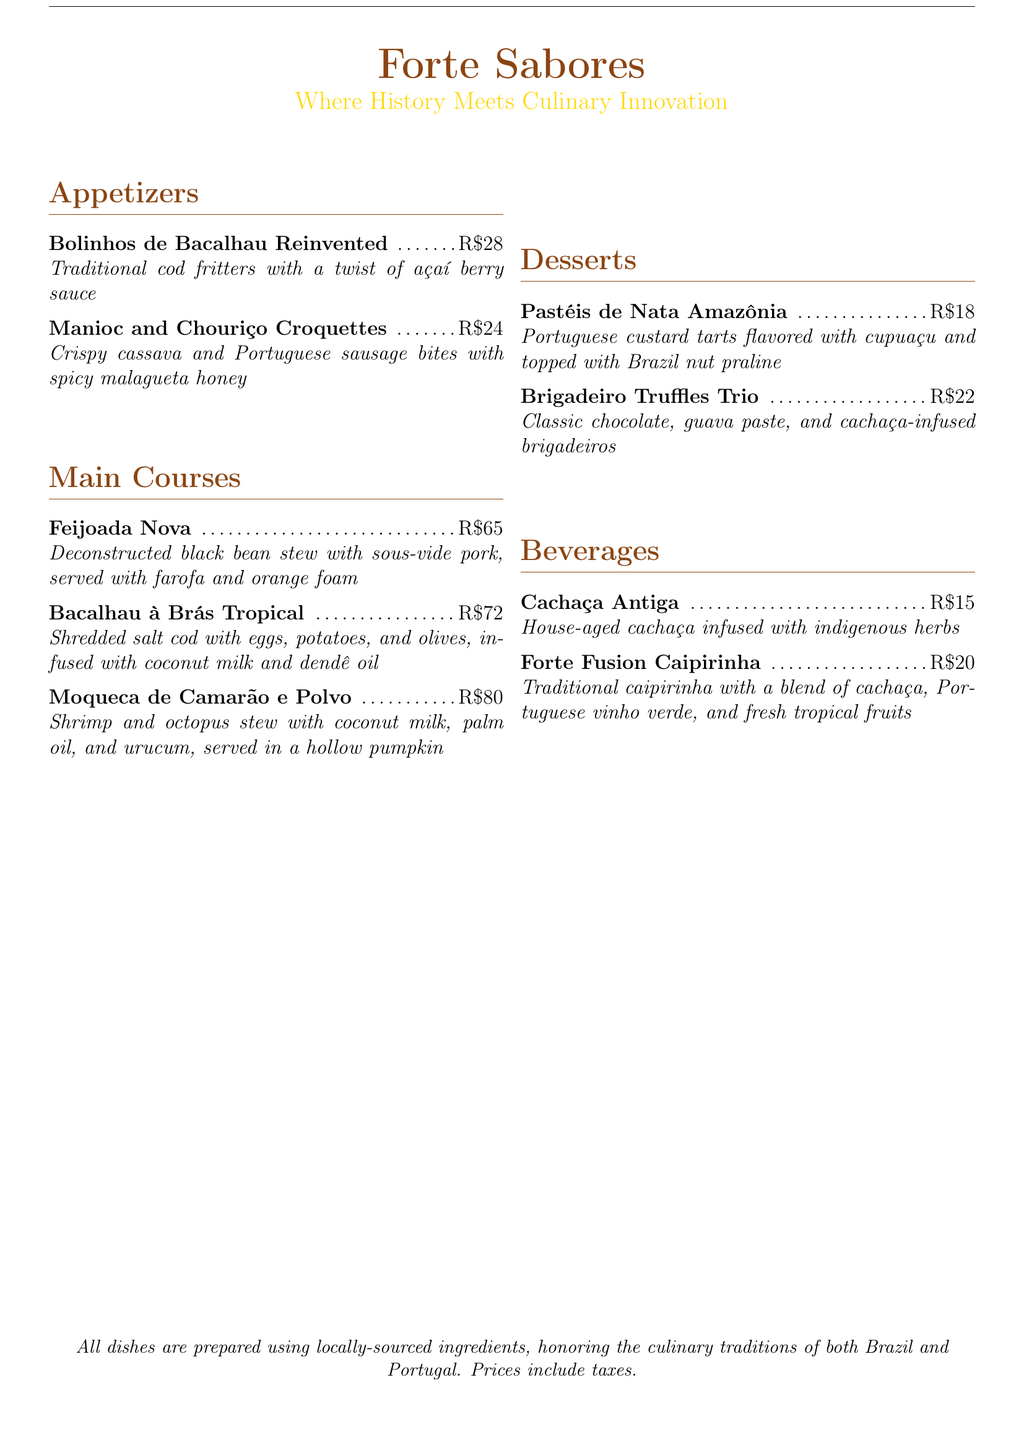What is the name of the restaurant? The restaurant is titled "Forte Sabores" as seen in the header.
Answer: Forte Sabores How much do the Bolinhos de Bacalhau Reinvented cost? The price for Bolinhos de Bacalhau Reinvented is listed directly in the menu as R\$28.
Answer: R\$28 What main course includes sous-vide pork? The menu specifies that Feijoada Nova includes sous-vide pork in its description.
Answer: Feijoada Nova What is the unique ingredient in the Brigadeiro Truffles Trio? The description lists guava paste as one of the unique ingredients in the Brigadeiro Truffles Trio.
Answer: Guava paste How many appetizers are listed on the menu? There are two appetizers listed under the Appetizers section of the menu.
Answer: 2 What beverage is described as being house-aged? The beverage menu specifically mentions "Cachaça Antiga" as being house-aged.
Answer: Cachaça Antiga Which dessert features cupuaçu? The dessert menu indicates that Pastéis de Nata Amazônia includes cupuaçu in its ingredients.
Answer: Pastéis de Nata Amazônia What is the price of the Moqueca de Camarão e Polvo? The menu clearly states that the price for Moqueca de Camarão e Polvo is R\$80.
Answer: R\$80 What type of fish is used in Bacalhau à Brás Tropical? The menu identifies that shredded salt cod is used in Bacalhau à Brás Tropical.
Answer: Salt cod 